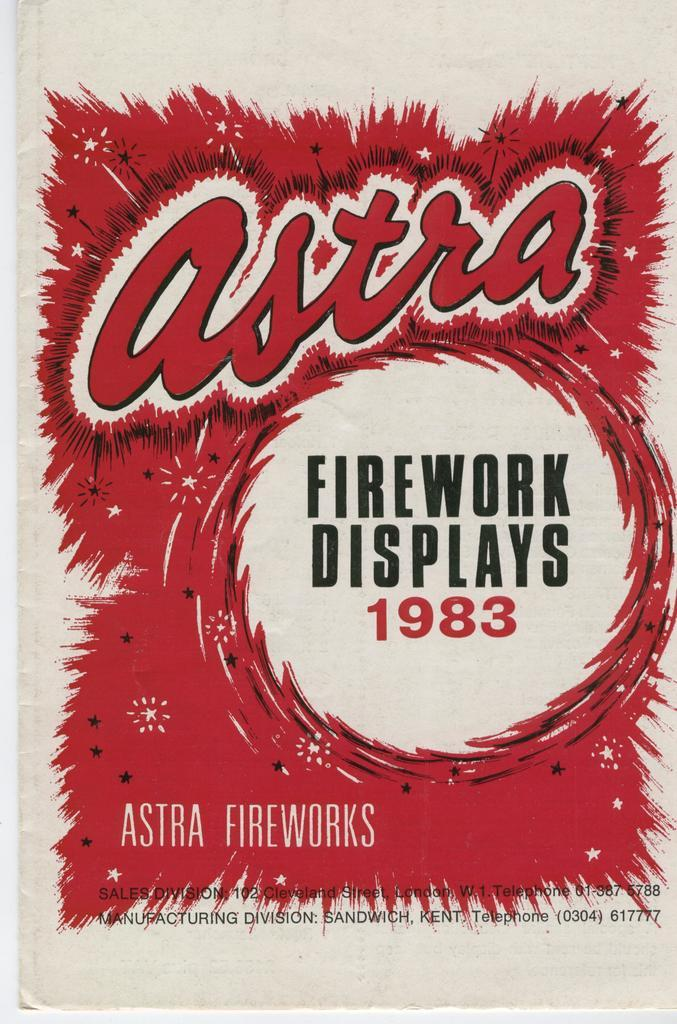<image>
Render a clear and concise summary of the photo. Fireworks displays are brought to you by Astra since 1983. 